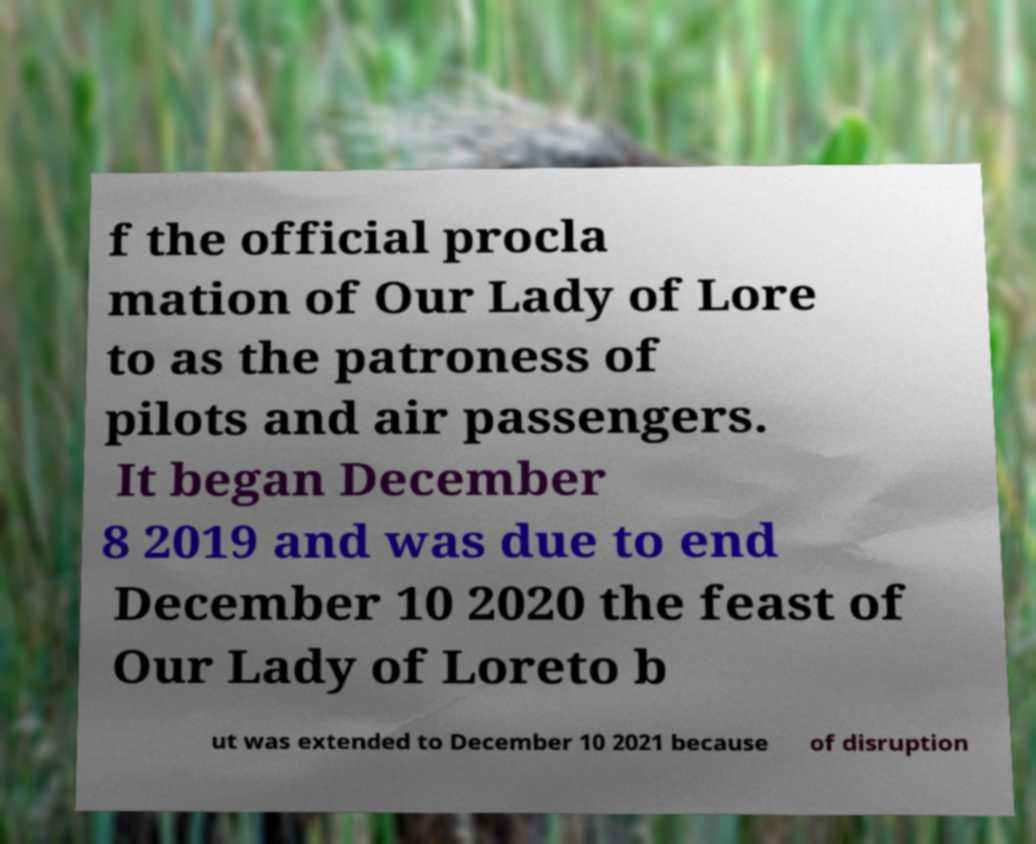Can you read and provide the text displayed in the image?This photo seems to have some interesting text. Can you extract and type it out for me? f the official procla mation of Our Lady of Lore to as the patroness of pilots and air passengers. It began December 8 2019 and was due to end December 10 2020 the feast of Our Lady of Loreto b ut was extended to December 10 2021 because of disruption 